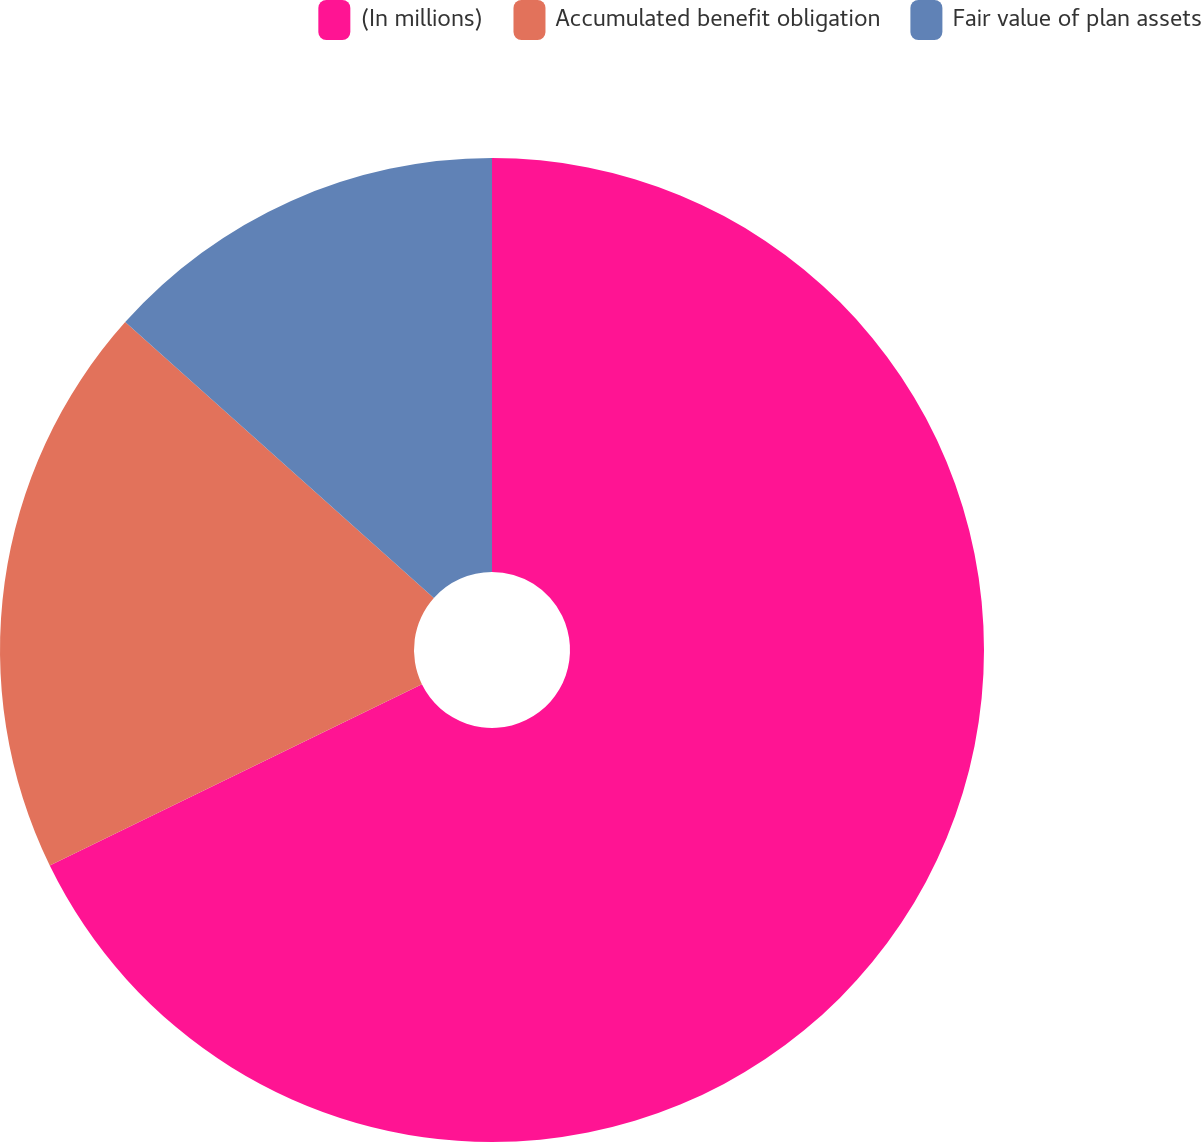Convert chart. <chart><loc_0><loc_0><loc_500><loc_500><pie_chart><fcel>(In millions)<fcel>Accumulated benefit obligation<fcel>Fair value of plan assets<nl><fcel>67.78%<fcel>18.83%<fcel>13.39%<nl></chart> 